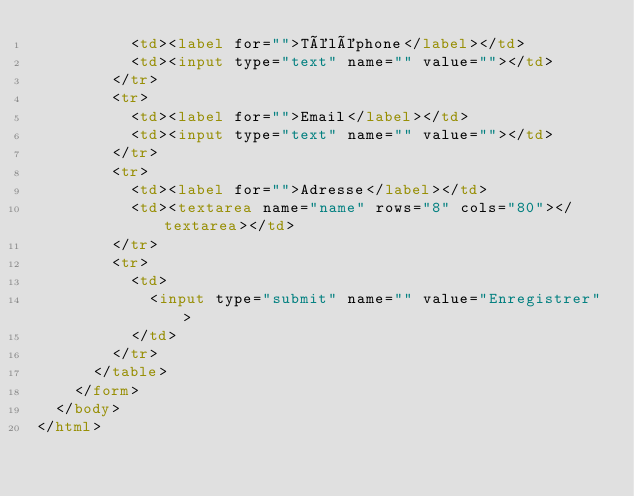<code> <loc_0><loc_0><loc_500><loc_500><_HTML_>          <td><label for="">Téléphone</label></td>
          <td><input type="text" name="" value=""></td>
        </tr>
        <tr>
          <td><label for="">Email</label></td>
          <td><input type="text" name="" value=""></td>
        </tr>
        <tr>
          <td><label for="">Adresse</label></td>
          <td><textarea name="name" rows="8" cols="80"></textarea></td>
        </tr>
        <tr>
          <td>
            <input type="submit" name="" value="Enregistrer">
          </td>
        </tr>
      </table>
    </form>
  </body>
</html>
</code> 